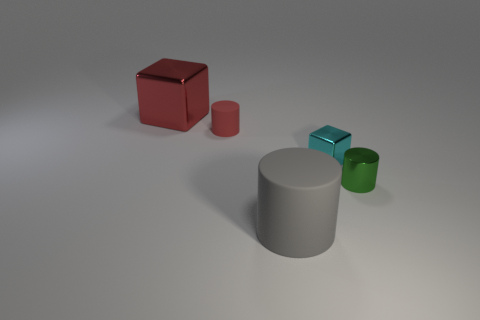Is there anything else that is the same size as the cyan object? Yes, the green cylindrical object appears to be nearly identical in height and diameter to the cyan object. 